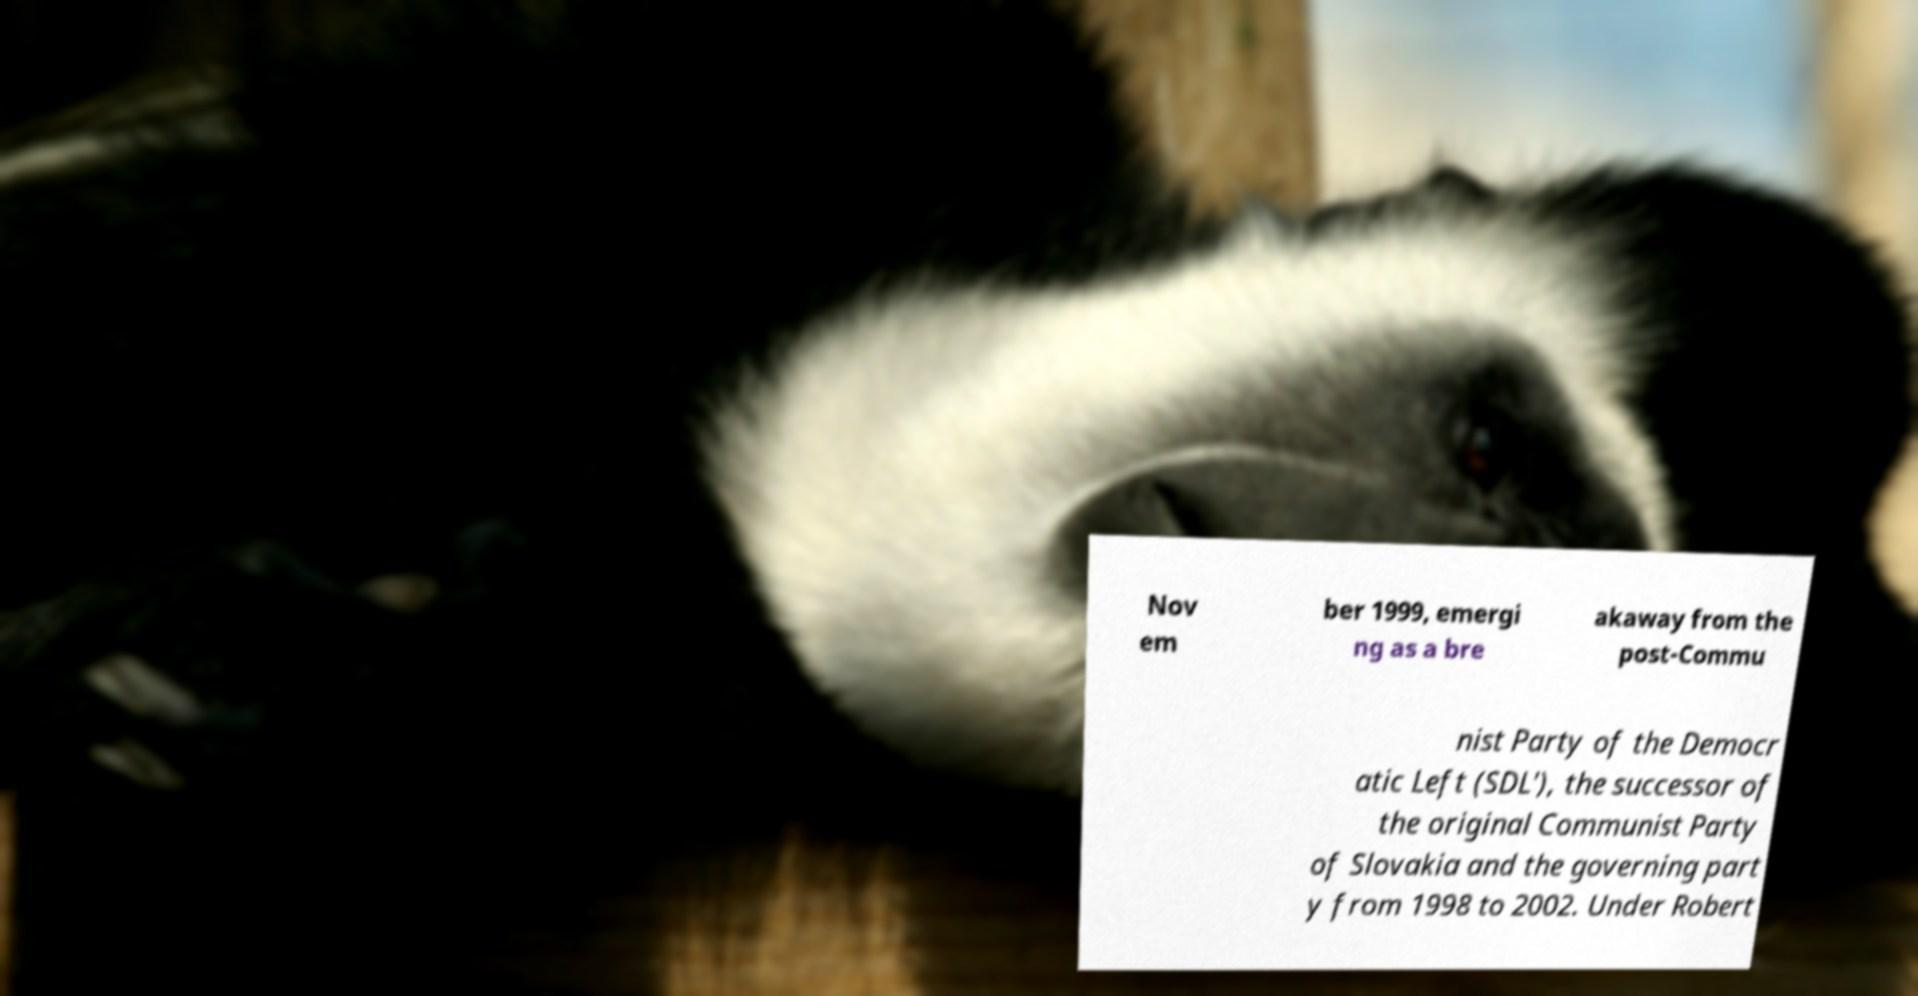What messages or text are displayed in this image? I need them in a readable, typed format. Nov em ber 1999, emergi ng as a bre akaway from the post-Commu nist Party of the Democr atic Left (SDL'), the successor of the original Communist Party of Slovakia and the governing part y from 1998 to 2002. Under Robert 